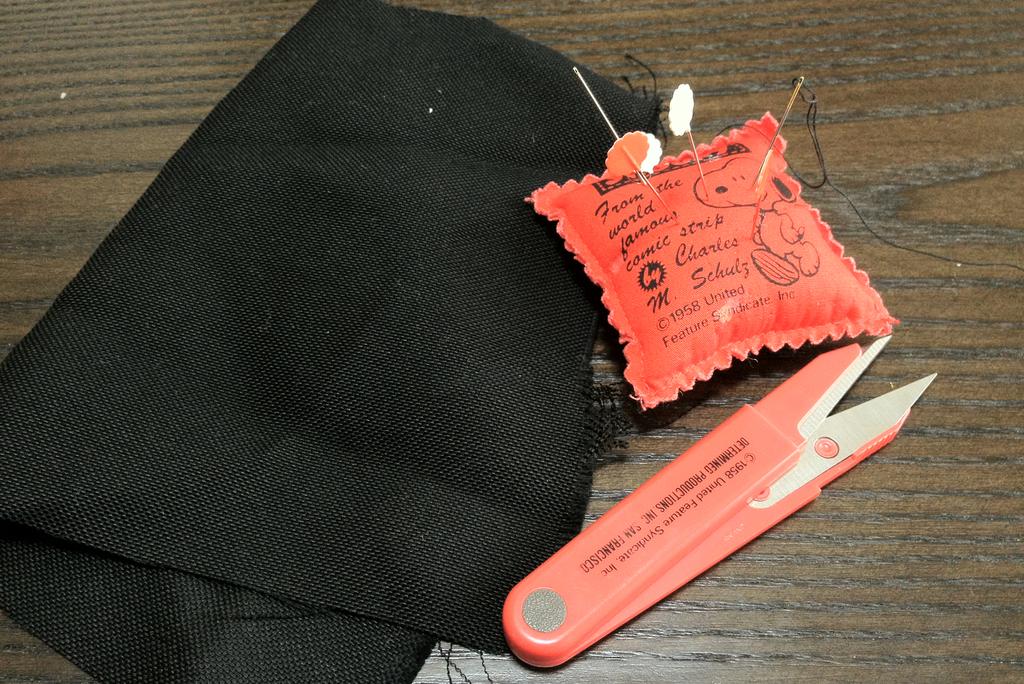What year is mentioned on the miniature pillow/?
Your answer should be compact. 1958. 